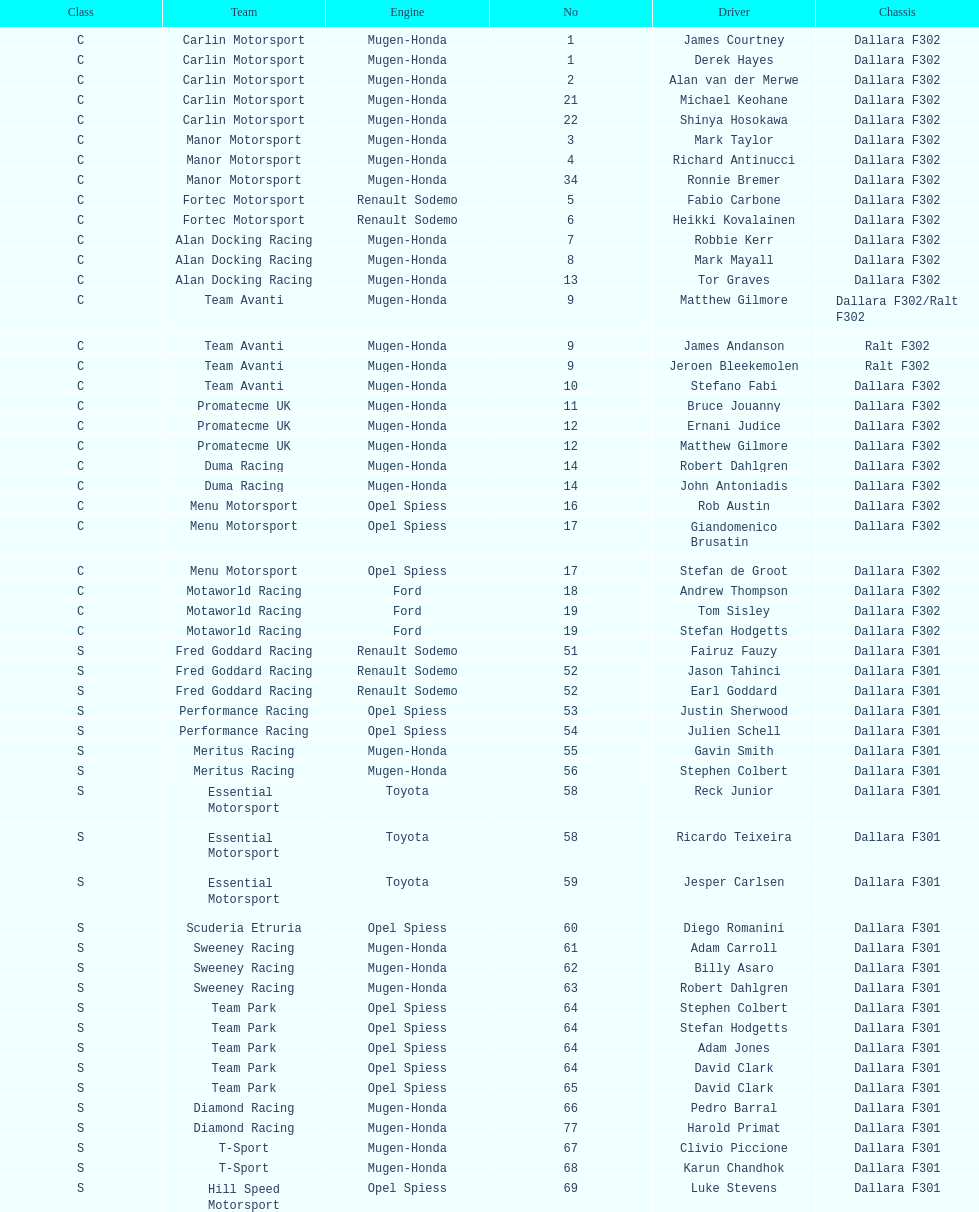What is the number of teams that had drivers all from the same country? 4. 